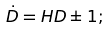Convert formula to latex. <formula><loc_0><loc_0><loc_500><loc_500>\dot { D } = H D \pm 1 ;</formula> 